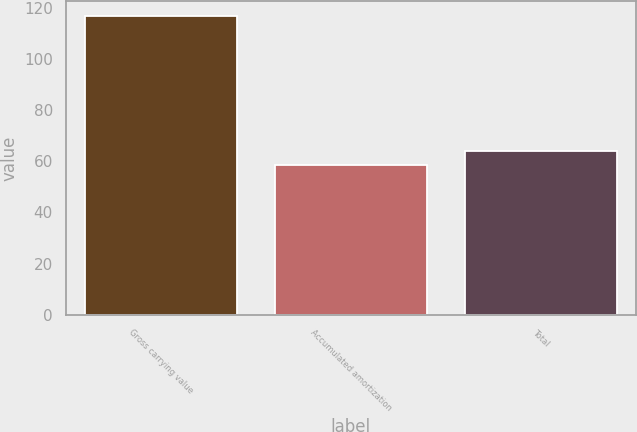Convert chart. <chart><loc_0><loc_0><loc_500><loc_500><bar_chart><fcel>Gross carrying value<fcel>Accumulated amortization<fcel>Total<nl><fcel>116.8<fcel>58.4<fcel>64.24<nl></chart> 